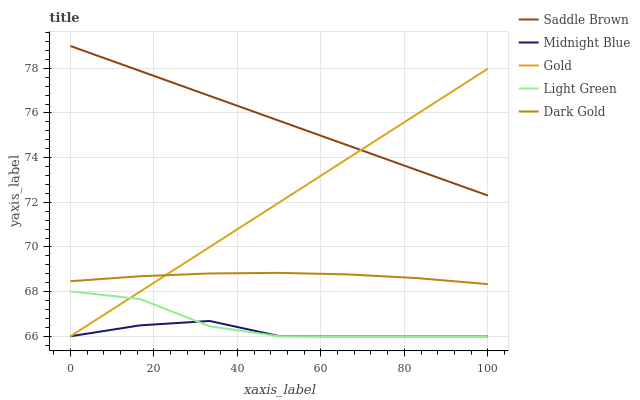Does Midnight Blue have the minimum area under the curve?
Answer yes or no. Yes. Does Saddle Brown have the maximum area under the curve?
Answer yes or no. Yes. Does Light Green have the minimum area under the curve?
Answer yes or no. No. Does Light Green have the maximum area under the curve?
Answer yes or no. No. Is Gold the smoothest?
Answer yes or no. Yes. Is Light Green the roughest?
Answer yes or no. Yes. Is Saddle Brown the smoothest?
Answer yes or no. No. Is Saddle Brown the roughest?
Answer yes or no. No. Does Light Green have the lowest value?
Answer yes or no. Yes. Does Saddle Brown have the lowest value?
Answer yes or no. No. Does Saddle Brown have the highest value?
Answer yes or no. Yes. Does Light Green have the highest value?
Answer yes or no. No. Is Light Green less than Dark Gold?
Answer yes or no. Yes. Is Saddle Brown greater than Dark Gold?
Answer yes or no. Yes. Does Midnight Blue intersect Gold?
Answer yes or no. Yes. Is Midnight Blue less than Gold?
Answer yes or no. No. Is Midnight Blue greater than Gold?
Answer yes or no. No. Does Light Green intersect Dark Gold?
Answer yes or no. No. 